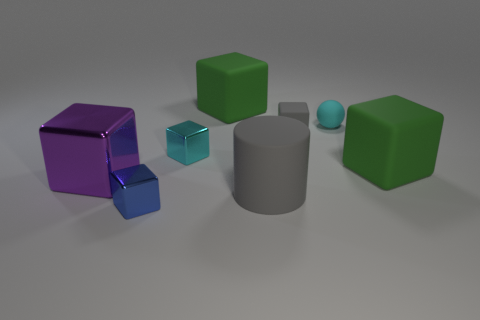Subtract all gray spheres. How many green blocks are left? 2 Subtract all cyan blocks. How many blocks are left? 5 Subtract all purple shiny blocks. How many blocks are left? 5 Subtract all blue cubes. Subtract all blue cylinders. How many cubes are left? 5 Add 1 small yellow rubber things. How many objects exist? 9 Subtract all small green cylinders. Subtract all large gray objects. How many objects are left? 7 Add 6 green matte cubes. How many green matte cubes are left? 8 Add 8 small cyan cubes. How many small cyan cubes exist? 9 Subtract 0 brown cylinders. How many objects are left? 8 Subtract all spheres. How many objects are left? 7 